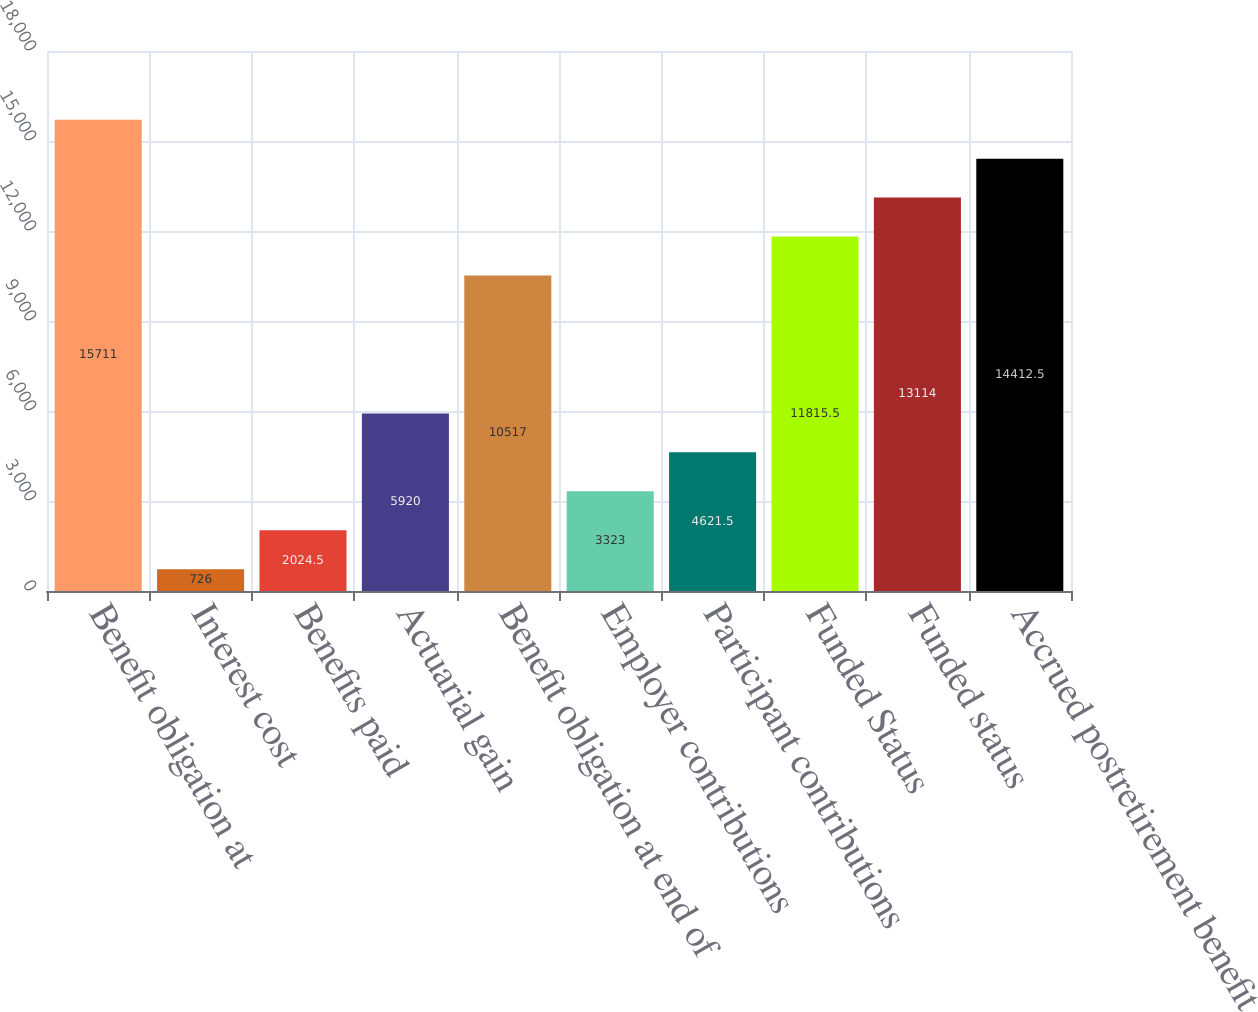<chart> <loc_0><loc_0><loc_500><loc_500><bar_chart><fcel>Benefit obligation at<fcel>Interest cost<fcel>Benefits paid<fcel>Actuarial gain<fcel>Benefit obligation at end of<fcel>Employer contributions<fcel>Participant contributions<fcel>Funded Status<fcel>Funded status<fcel>Accrued postretirement benefit<nl><fcel>15711<fcel>726<fcel>2024.5<fcel>5920<fcel>10517<fcel>3323<fcel>4621.5<fcel>11815.5<fcel>13114<fcel>14412.5<nl></chart> 